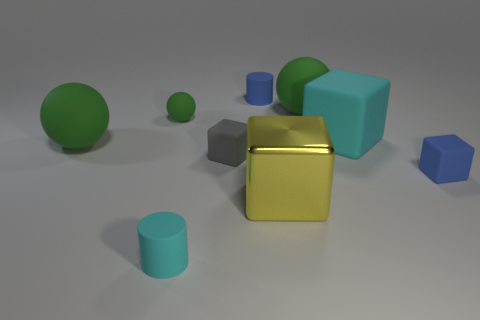What materials are the objects in the image made of? The objects in the image are designed to simulate materials such as rubber for the spheres and perhaps matte and metallic surfaces for the cylinders and cube respectively. They are rendered with different properties to give cues about their textures and finishes. 